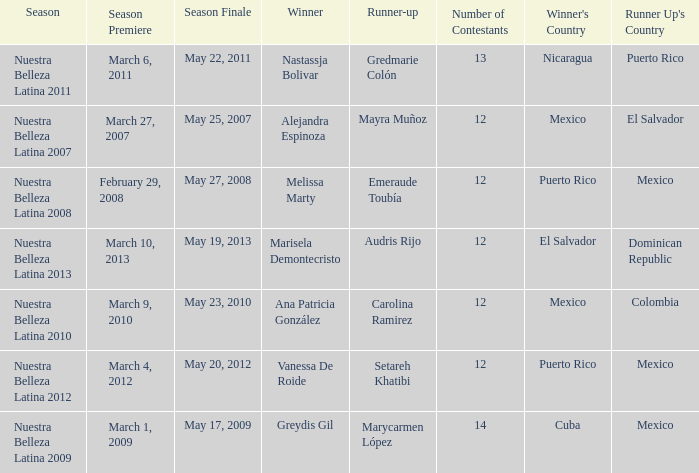What season had mexico as the runner up with melissa marty winning? Nuestra Belleza Latina 2008. 